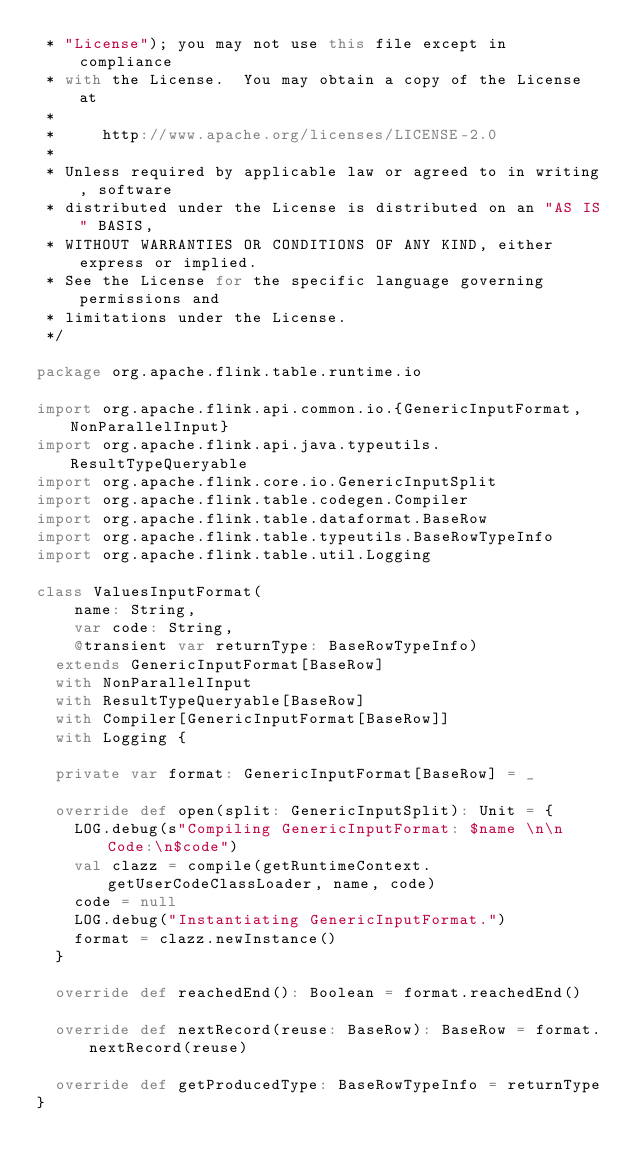Convert code to text. <code><loc_0><loc_0><loc_500><loc_500><_Scala_> * "License"); you may not use this file except in compliance
 * with the License.  You may obtain a copy of the License at
 *
 *     http://www.apache.org/licenses/LICENSE-2.0
 *
 * Unless required by applicable law or agreed to in writing, software
 * distributed under the License is distributed on an "AS IS" BASIS,
 * WITHOUT WARRANTIES OR CONDITIONS OF ANY KIND, either express or implied.
 * See the License for the specific language governing permissions and
 * limitations under the License.
 */

package org.apache.flink.table.runtime.io

import org.apache.flink.api.common.io.{GenericInputFormat, NonParallelInput}
import org.apache.flink.api.java.typeutils.ResultTypeQueryable
import org.apache.flink.core.io.GenericInputSplit
import org.apache.flink.table.codegen.Compiler
import org.apache.flink.table.dataformat.BaseRow
import org.apache.flink.table.typeutils.BaseRowTypeInfo
import org.apache.flink.table.util.Logging

class ValuesInputFormat(
    name: String,
    var code: String,
    @transient var returnType: BaseRowTypeInfo)
  extends GenericInputFormat[BaseRow]
  with NonParallelInput
  with ResultTypeQueryable[BaseRow]
  with Compiler[GenericInputFormat[BaseRow]]
  with Logging {

  private var format: GenericInputFormat[BaseRow] = _

  override def open(split: GenericInputSplit): Unit = {
    LOG.debug(s"Compiling GenericInputFormat: $name \n\n Code:\n$code")
    val clazz = compile(getRuntimeContext.getUserCodeClassLoader, name, code)
    code = null
    LOG.debug("Instantiating GenericInputFormat.")
    format = clazz.newInstance()
  }

  override def reachedEnd(): Boolean = format.reachedEnd()

  override def nextRecord(reuse: BaseRow): BaseRow = format.nextRecord(reuse)

  override def getProducedType: BaseRowTypeInfo = returnType
}
</code> 